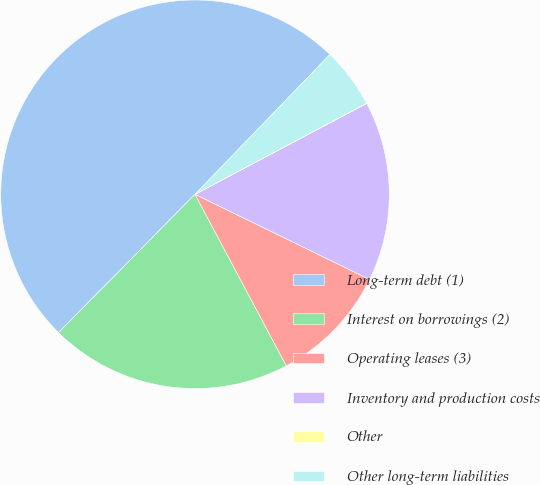Convert chart. <chart><loc_0><loc_0><loc_500><loc_500><pie_chart><fcel>Long-term debt (1)<fcel>Interest on borrowings (2)<fcel>Operating leases (3)<fcel>Inventory and production costs<fcel>Other<fcel>Other long-term liabilities<nl><fcel>49.82%<fcel>20.18%<fcel>9.99%<fcel>14.97%<fcel>0.03%<fcel>5.01%<nl></chart> 